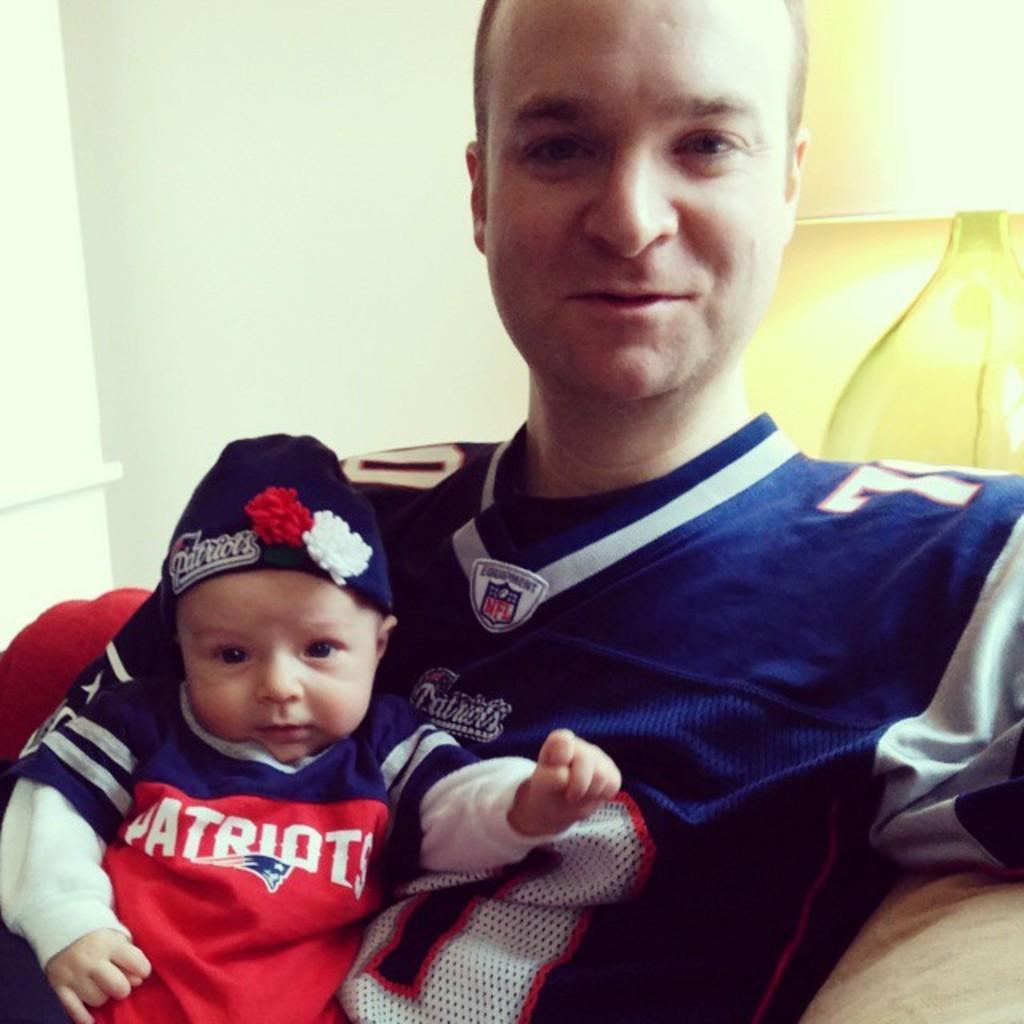<image>
Share a concise interpretation of the image provided. A man proudly holds his baby who wears a red patriots strip. 